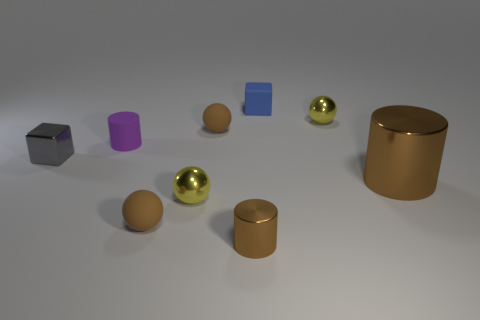Subtract all large brown metallic cylinders. How many cylinders are left? 2 Subtract all purple cylinders. How many cylinders are left? 2 Subtract all cubes. How many objects are left? 7 Subtract 1 balls. How many balls are left? 3 Subtract all brown rubber spheres. Subtract all tiny brown metal cylinders. How many objects are left? 6 Add 2 small blue rubber cubes. How many small blue rubber cubes are left? 3 Add 7 tiny purple shiny cylinders. How many tiny purple shiny cylinders exist? 7 Add 1 small blue objects. How many objects exist? 10 Subtract 0 green cylinders. How many objects are left? 9 Subtract all purple cubes. Subtract all red balls. How many cubes are left? 2 